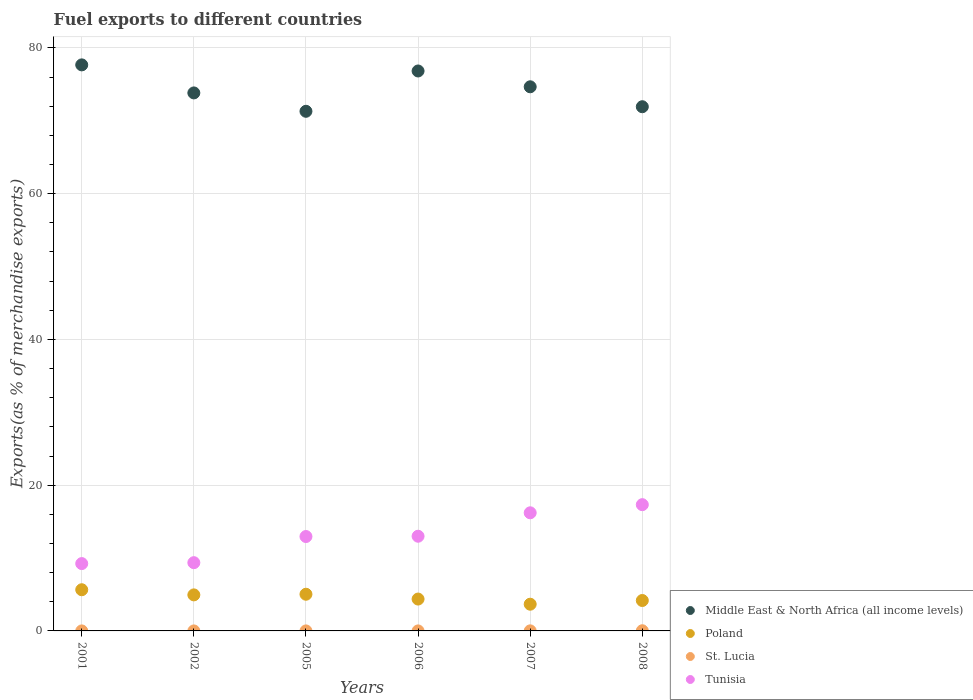What is the percentage of exports to different countries in Tunisia in 2005?
Provide a short and direct response. 12.95. Across all years, what is the maximum percentage of exports to different countries in Middle East & North Africa (all income levels)?
Offer a very short reply. 77.67. Across all years, what is the minimum percentage of exports to different countries in Middle East & North Africa (all income levels)?
Your response must be concise. 71.3. In which year was the percentage of exports to different countries in Poland minimum?
Provide a succinct answer. 2007. What is the total percentage of exports to different countries in St. Lucia in the graph?
Your answer should be compact. 0.04. What is the difference between the percentage of exports to different countries in Middle East & North Africa (all income levels) in 2007 and that in 2008?
Give a very brief answer. 2.74. What is the difference between the percentage of exports to different countries in St. Lucia in 2006 and the percentage of exports to different countries in Middle East & North Africa (all income levels) in 2001?
Make the answer very short. -77.67. What is the average percentage of exports to different countries in Poland per year?
Provide a succinct answer. 4.64. In the year 2007, what is the difference between the percentage of exports to different countries in Tunisia and percentage of exports to different countries in St. Lucia?
Your answer should be very brief. 16.2. What is the ratio of the percentage of exports to different countries in Middle East & North Africa (all income levels) in 2001 to that in 2005?
Ensure brevity in your answer.  1.09. Is the percentage of exports to different countries in Middle East & North Africa (all income levels) in 2002 less than that in 2006?
Your response must be concise. Yes. What is the difference between the highest and the second highest percentage of exports to different countries in Middle East & North Africa (all income levels)?
Provide a succinct answer. 0.84. What is the difference between the highest and the lowest percentage of exports to different countries in Middle East & North Africa (all income levels)?
Give a very brief answer. 6.37. In how many years, is the percentage of exports to different countries in St. Lucia greater than the average percentage of exports to different countries in St. Lucia taken over all years?
Offer a terse response. 2. Is it the case that in every year, the sum of the percentage of exports to different countries in Tunisia and percentage of exports to different countries in St. Lucia  is greater than the sum of percentage of exports to different countries in Middle East & North Africa (all income levels) and percentage of exports to different countries in Poland?
Provide a short and direct response. Yes. Is it the case that in every year, the sum of the percentage of exports to different countries in Tunisia and percentage of exports to different countries in St. Lucia  is greater than the percentage of exports to different countries in Poland?
Your answer should be compact. Yes. Does the percentage of exports to different countries in St. Lucia monotonically increase over the years?
Provide a succinct answer. No. Is the percentage of exports to different countries in Tunisia strictly greater than the percentage of exports to different countries in St. Lucia over the years?
Your response must be concise. Yes. Is the percentage of exports to different countries in Middle East & North Africa (all income levels) strictly less than the percentage of exports to different countries in Tunisia over the years?
Provide a succinct answer. No. How many dotlines are there?
Offer a terse response. 4. How many years are there in the graph?
Offer a very short reply. 6. Does the graph contain any zero values?
Offer a terse response. No. Does the graph contain grids?
Offer a very short reply. Yes. How are the legend labels stacked?
Give a very brief answer. Vertical. What is the title of the graph?
Make the answer very short. Fuel exports to different countries. Does "Bulgaria" appear as one of the legend labels in the graph?
Offer a very short reply. No. What is the label or title of the Y-axis?
Your answer should be compact. Exports(as % of merchandise exports). What is the Exports(as % of merchandise exports) in Middle East & North Africa (all income levels) in 2001?
Provide a succinct answer. 77.67. What is the Exports(as % of merchandise exports) of Poland in 2001?
Your answer should be compact. 5.65. What is the Exports(as % of merchandise exports) of St. Lucia in 2001?
Your answer should be compact. 0. What is the Exports(as % of merchandise exports) in Tunisia in 2001?
Make the answer very short. 9.24. What is the Exports(as % of merchandise exports) of Middle East & North Africa (all income levels) in 2002?
Offer a terse response. 73.82. What is the Exports(as % of merchandise exports) in Poland in 2002?
Give a very brief answer. 4.94. What is the Exports(as % of merchandise exports) in St. Lucia in 2002?
Offer a very short reply. 4.657797227082891e-6. What is the Exports(as % of merchandise exports) in Tunisia in 2002?
Your answer should be compact. 9.36. What is the Exports(as % of merchandise exports) of Middle East & North Africa (all income levels) in 2005?
Your response must be concise. 71.3. What is the Exports(as % of merchandise exports) in Poland in 2005?
Your answer should be compact. 5.03. What is the Exports(as % of merchandise exports) in St. Lucia in 2005?
Provide a short and direct response. 0. What is the Exports(as % of merchandise exports) in Tunisia in 2005?
Keep it short and to the point. 12.95. What is the Exports(as % of merchandise exports) of Middle East & North Africa (all income levels) in 2006?
Provide a short and direct response. 76.83. What is the Exports(as % of merchandise exports) of Poland in 2006?
Provide a succinct answer. 4.37. What is the Exports(as % of merchandise exports) of St. Lucia in 2006?
Your answer should be very brief. 0. What is the Exports(as % of merchandise exports) of Tunisia in 2006?
Provide a short and direct response. 12.99. What is the Exports(as % of merchandise exports) of Middle East & North Africa (all income levels) in 2007?
Keep it short and to the point. 74.66. What is the Exports(as % of merchandise exports) in Poland in 2007?
Offer a terse response. 3.67. What is the Exports(as % of merchandise exports) in St. Lucia in 2007?
Keep it short and to the point. 0.01. What is the Exports(as % of merchandise exports) of Tunisia in 2007?
Make the answer very short. 16.21. What is the Exports(as % of merchandise exports) in Middle East & North Africa (all income levels) in 2008?
Keep it short and to the point. 71.93. What is the Exports(as % of merchandise exports) in Poland in 2008?
Give a very brief answer. 4.17. What is the Exports(as % of merchandise exports) in St. Lucia in 2008?
Your response must be concise. 0.02. What is the Exports(as % of merchandise exports) of Tunisia in 2008?
Give a very brief answer. 17.32. Across all years, what is the maximum Exports(as % of merchandise exports) of Middle East & North Africa (all income levels)?
Ensure brevity in your answer.  77.67. Across all years, what is the maximum Exports(as % of merchandise exports) of Poland?
Make the answer very short. 5.65. Across all years, what is the maximum Exports(as % of merchandise exports) of St. Lucia?
Provide a short and direct response. 0.02. Across all years, what is the maximum Exports(as % of merchandise exports) in Tunisia?
Your answer should be compact. 17.32. Across all years, what is the minimum Exports(as % of merchandise exports) of Middle East & North Africa (all income levels)?
Give a very brief answer. 71.3. Across all years, what is the minimum Exports(as % of merchandise exports) in Poland?
Give a very brief answer. 3.67. Across all years, what is the minimum Exports(as % of merchandise exports) of St. Lucia?
Offer a very short reply. 4.657797227082891e-6. Across all years, what is the minimum Exports(as % of merchandise exports) of Tunisia?
Give a very brief answer. 9.24. What is the total Exports(as % of merchandise exports) of Middle East & North Africa (all income levels) in the graph?
Make the answer very short. 446.21. What is the total Exports(as % of merchandise exports) of Poland in the graph?
Your response must be concise. 27.84. What is the total Exports(as % of merchandise exports) of St. Lucia in the graph?
Offer a very short reply. 0.04. What is the total Exports(as % of merchandise exports) of Tunisia in the graph?
Offer a very short reply. 78.08. What is the difference between the Exports(as % of merchandise exports) in Middle East & North Africa (all income levels) in 2001 and that in 2002?
Offer a very short reply. 3.85. What is the difference between the Exports(as % of merchandise exports) in Poland in 2001 and that in 2002?
Your answer should be very brief. 0.71. What is the difference between the Exports(as % of merchandise exports) in St. Lucia in 2001 and that in 2002?
Provide a short and direct response. 0. What is the difference between the Exports(as % of merchandise exports) of Tunisia in 2001 and that in 2002?
Give a very brief answer. -0.13. What is the difference between the Exports(as % of merchandise exports) of Middle East & North Africa (all income levels) in 2001 and that in 2005?
Your answer should be compact. 6.37. What is the difference between the Exports(as % of merchandise exports) in Poland in 2001 and that in 2005?
Your answer should be very brief. 0.62. What is the difference between the Exports(as % of merchandise exports) in St. Lucia in 2001 and that in 2005?
Keep it short and to the point. -0. What is the difference between the Exports(as % of merchandise exports) in Tunisia in 2001 and that in 2005?
Offer a very short reply. -3.71. What is the difference between the Exports(as % of merchandise exports) in Middle East & North Africa (all income levels) in 2001 and that in 2006?
Offer a terse response. 0.84. What is the difference between the Exports(as % of merchandise exports) of Poland in 2001 and that in 2006?
Offer a very short reply. 1.28. What is the difference between the Exports(as % of merchandise exports) in St. Lucia in 2001 and that in 2006?
Your answer should be compact. -0. What is the difference between the Exports(as % of merchandise exports) in Tunisia in 2001 and that in 2006?
Your answer should be compact. -3.75. What is the difference between the Exports(as % of merchandise exports) in Middle East & North Africa (all income levels) in 2001 and that in 2007?
Your answer should be compact. 3.01. What is the difference between the Exports(as % of merchandise exports) in Poland in 2001 and that in 2007?
Make the answer very short. 1.99. What is the difference between the Exports(as % of merchandise exports) of St. Lucia in 2001 and that in 2007?
Your answer should be very brief. -0.01. What is the difference between the Exports(as % of merchandise exports) of Tunisia in 2001 and that in 2007?
Ensure brevity in your answer.  -6.97. What is the difference between the Exports(as % of merchandise exports) in Middle East & North Africa (all income levels) in 2001 and that in 2008?
Your answer should be very brief. 5.74. What is the difference between the Exports(as % of merchandise exports) in Poland in 2001 and that in 2008?
Your response must be concise. 1.48. What is the difference between the Exports(as % of merchandise exports) in St. Lucia in 2001 and that in 2008?
Provide a succinct answer. -0.02. What is the difference between the Exports(as % of merchandise exports) of Tunisia in 2001 and that in 2008?
Provide a succinct answer. -8.09. What is the difference between the Exports(as % of merchandise exports) in Middle East & North Africa (all income levels) in 2002 and that in 2005?
Offer a very short reply. 2.52. What is the difference between the Exports(as % of merchandise exports) in Poland in 2002 and that in 2005?
Offer a terse response. -0.09. What is the difference between the Exports(as % of merchandise exports) of St. Lucia in 2002 and that in 2005?
Provide a short and direct response. -0. What is the difference between the Exports(as % of merchandise exports) of Tunisia in 2002 and that in 2005?
Make the answer very short. -3.59. What is the difference between the Exports(as % of merchandise exports) of Middle East & North Africa (all income levels) in 2002 and that in 2006?
Make the answer very short. -3.01. What is the difference between the Exports(as % of merchandise exports) in Poland in 2002 and that in 2006?
Your answer should be very brief. 0.57. What is the difference between the Exports(as % of merchandise exports) of St. Lucia in 2002 and that in 2006?
Ensure brevity in your answer.  -0. What is the difference between the Exports(as % of merchandise exports) in Tunisia in 2002 and that in 2006?
Make the answer very short. -3.63. What is the difference between the Exports(as % of merchandise exports) in Middle East & North Africa (all income levels) in 2002 and that in 2007?
Keep it short and to the point. -0.84. What is the difference between the Exports(as % of merchandise exports) in Poland in 2002 and that in 2007?
Your response must be concise. 1.28. What is the difference between the Exports(as % of merchandise exports) in St. Lucia in 2002 and that in 2007?
Your answer should be compact. -0.01. What is the difference between the Exports(as % of merchandise exports) of Tunisia in 2002 and that in 2007?
Make the answer very short. -6.84. What is the difference between the Exports(as % of merchandise exports) of Middle East & North Africa (all income levels) in 2002 and that in 2008?
Provide a succinct answer. 1.89. What is the difference between the Exports(as % of merchandise exports) in Poland in 2002 and that in 2008?
Offer a very short reply. 0.77. What is the difference between the Exports(as % of merchandise exports) in St. Lucia in 2002 and that in 2008?
Provide a succinct answer. -0.02. What is the difference between the Exports(as % of merchandise exports) in Tunisia in 2002 and that in 2008?
Offer a very short reply. -7.96. What is the difference between the Exports(as % of merchandise exports) of Middle East & North Africa (all income levels) in 2005 and that in 2006?
Give a very brief answer. -5.53. What is the difference between the Exports(as % of merchandise exports) in Poland in 2005 and that in 2006?
Your answer should be compact. 0.66. What is the difference between the Exports(as % of merchandise exports) in St. Lucia in 2005 and that in 2006?
Make the answer very short. -0. What is the difference between the Exports(as % of merchandise exports) of Tunisia in 2005 and that in 2006?
Your response must be concise. -0.04. What is the difference between the Exports(as % of merchandise exports) in Middle East & North Africa (all income levels) in 2005 and that in 2007?
Make the answer very short. -3.36. What is the difference between the Exports(as % of merchandise exports) of Poland in 2005 and that in 2007?
Keep it short and to the point. 1.37. What is the difference between the Exports(as % of merchandise exports) of St. Lucia in 2005 and that in 2007?
Ensure brevity in your answer.  -0.01. What is the difference between the Exports(as % of merchandise exports) of Tunisia in 2005 and that in 2007?
Keep it short and to the point. -3.26. What is the difference between the Exports(as % of merchandise exports) in Middle East & North Africa (all income levels) in 2005 and that in 2008?
Your response must be concise. -0.63. What is the difference between the Exports(as % of merchandise exports) of Poland in 2005 and that in 2008?
Give a very brief answer. 0.86. What is the difference between the Exports(as % of merchandise exports) of St. Lucia in 2005 and that in 2008?
Make the answer very short. -0.02. What is the difference between the Exports(as % of merchandise exports) in Tunisia in 2005 and that in 2008?
Provide a succinct answer. -4.37. What is the difference between the Exports(as % of merchandise exports) of Middle East & North Africa (all income levels) in 2006 and that in 2007?
Your answer should be very brief. 2.17. What is the difference between the Exports(as % of merchandise exports) of Poland in 2006 and that in 2007?
Provide a short and direct response. 0.71. What is the difference between the Exports(as % of merchandise exports) in St. Lucia in 2006 and that in 2007?
Offer a terse response. -0.01. What is the difference between the Exports(as % of merchandise exports) in Tunisia in 2006 and that in 2007?
Ensure brevity in your answer.  -3.21. What is the difference between the Exports(as % of merchandise exports) in Middle East & North Africa (all income levels) in 2006 and that in 2008?
Your response must be concise. 4.91. What is the difference between the Exports(as % of merchandise exports) of Poland in 2006 and that in 2008?
Provide a short and direct response. 0.2. What is the difference between the Exports(as % of merchandise exports) in St. Lucia in 2006 and that in 2008?
Give a very brief answer. -0.02. What is the difference between the Exports(as % of merchandise exports) in Tunisia in 2006 and that in 2008?
Offer a very short reply. -4.33. What is the difference between the Exports(as % of merchandise exports) in Middle East & North Africa (all income levels) in 2007 and that in 2008?
Your answer should be very brief. 2.74. What is the difference between the Exports(as % of merchandise exports) of Poland in 2007 and that in 2008?
Offer a very short reply. -0.51. What is the difference between the Exports(as % of merchandise exports) of St. Lucia in 2007 and that in 2008?
Offer a very short reply. -0.01. What is the difference between the Exports(as % of merchandise exports) in Tunisia in 2007 and that in 2008?
Provide a short and direct response. -1.12. What is the difference between the Exports(as % of merchandise exports) of Middle East & North Africa (all income levels) in 2001 and the Exports(as % of merchandise exports) of Poland in 2002?
Your answer should be compact. 72.72. What is the difference between the Exports(as % of merchandise exports) of Middle East & North Africa (all income levels) in 2001 and the Exports(as % of merchandise exports) of St. Lucia in 2002?
Your response must be concise. 77.67. What is the difference between the Exports(as % of merchandise exports) in Middle East & North Africa (all income levels) in 2001 and the Exports(as % of merchandise exports) in Tunisia in 2002?
Offer a terse response. 68.3. What is the difference between the Exports(as % of merchandise exports) in Poland in 2001 and the Exports(as % of merchandise exports) in St. Lucia in 2002?
Provide a succinct answer. 5.65. What is the difference between the Exports(as % of merchandise exports) of Poland in 2001 and the Exports(as % of merchandise exports) of Tunisia in 2002?
Provide a short and direct response. -3.71. What is the difference between the Exports(as % of merchandise exports) of St. Lucia in 2001 and the Exports(as % of merchandise exports) of Tunisia in 2002?
Give a very brief answer. -9.36. What is the difference between the Exports(as % of merchandise exports) of Middle East & North Africa (all income levels) in 2001 and the Exports(as % of merchandise exports) of Poland in 2005?
Your response must be concise. 72.64. What is the difference between the Exports(as % of merchandise exports) of Middle East & North Africa (all income levels) in 2001 and the Exports(as % of merchandise exports) of St. Lucia in 2005?
Keep it short and to the point. 77.67. What is the difference between the Exports(as % of merchandise exports) in Middle East & North Africa (all income levels) in 2001 and the Exports(as % of merchandise exports) in Tunisia in 2005?
Your answer should be compact. 64.72. What is the difference between the Exports(as % of merchandise exports) in Poland in 2001 and the Exports(as % of merchandise exports) in St. Lucia in 2005?
Your response must be concise. 5.65. What is the difference between the Exports(as % of merchandise exports) in Poland in 2001 and the Exports(as % of merchandise exports) in Tunisia in 2005?
Ensure brevity in your answer.  -7.3. What is the difference between the Exports(as % of merchandise exports) of St. Lucia in 2001 and the Exports(as % of merchandise exports) of Tunisia in 2005?
Ensure brevity in your answer.  -12.95. What is the difference between the Exports(as % of merchandise exports) in Middle East & North Africa (all income levels) in 2001 and the Exports(as % of merchandise exports) in Poland in 2006?
Provide a succinct answer. 73.3. What is the difference between the Exports(as % of merchandise exports) of Middle East & North Africa (all income levels) in 2001 and the Exports(as % of merchandise exports) of St. Lucia in 2006?
Your answer should be compact. 77.67. What is the difference between the Exports(as % of merchandise exports) of Middle East & North Africa (all income levels) in 2001 and the Exports(as % of merchandise exports) of Tunisia in 2006?
Ensure brevity in your answer.  64.68. What is the difference between the Exports(as % of merchandise exports) of Poland in 2001 and the Exports(as % of merchandise exports) of St. Lucia in 2006?
Provide a short and direct response. 5.65. What is the difference between the Exports(as % of merchandise exports) in Poland in 2001 and the Exports(as % of merchandise exports) in Tunisia in 2006?
Ensure brevity in your answer.  -7.34. What is the difference between the Exports(as % of merchandise exports) of St. Lucia in 2001 and the Exports(as % of merchandise exports) of Tunisia in 2006?
Offer a very short reply. -12.99. What is the difference between the Exports(as % of merchandise exports) in Middle East & North Africa (all income levels) in 2001 and the Exports(as % of merchandise exports) in Poland in 2007?
Your answer should be very brief. 74. What is the difference between the Exports(as % of merchandise exports) of Middle East & North Africa (all income levels) in 2001 and the Exports(as % of merchandise exports) of St. Lucia in 2007?
Provide a succinct answer. 77.66. What is the difference between the Exports(as % of merchandise exports) in Middle East & North Africa (all income levels) in 2001 and the Exports(as % of merchandise exports) in Tunisia in 2007?
Offer a very short reply. 61.46. What is the difference between the Exports(as % of merchandise exports) of Poland in 2001 and the Exports(as % of merchandise exports) of St. Lucia in 2007?
Give a very brief answer. 5.64. What is the difference between the Exports(as % of merchandise exports) in Poland in 2001 and the Exports(as % of merchandise exports) in Tunisia in 2007?
Make the answer very short. -10.56. What is the difference between the Exports(as % of merchandise exports) in St. Lucia in 2001 and the Exports(as % of merchandise exports) in Tunisia in 2007?
Provide a succinct answer. -16.21. What is the difference between the Exports(as % of merchandise exports) of Middle East & North Africa (all income levels) in 2001 and the Exports(as % of merchandise exports) of Poland in 2008?
Your response must be concise. 73.5. What is the difference between the Exports(as % of merchandise exports) in Middle East & North Africa (all income levels) in 2001 and the Exports(as % of merchandise exports) in St. Lucia in 2008?
Your answer should be very brief. 77.64. What is the difference between the Exports(as % of merchandise exports) in Middle East & North Africa (all income levels) in 2001 and the Exports(as % of merchandise exports) in Tunisia in 2008?
Make the answer very short. 60.34. What is the difference between the Exports(as % of merchandise exports) of Poland in 2001 and the Exports(as % of merchandise exports) of St. Lucia in 2008?
Your answer should be very brief. 5.63. What is the difference between the Exports(as % of merchandise exports) in Poland in 2001 and the Exports(as % of merchandise exports) in Tunisia in 2008?
Your answer should be compact. -11.67. What is the difference between the Exports(as % of merchandise exports) in St. Lucia in 2001 and the Exports(as % of merchandise exports) in Tunisia in 2008?
Your response must be concise. -17.32. What is the difference between the Exports(as % of merchandise exports) of Middle East & North Africa (all income levels) in 2002 and the Exports(as % of merchandise exports) of Poland in 2005?
Offer a terse response. 68.79. What is the difference between the Exports(as % of merchandise exports) of Middle East & North Africa (all income levels) in 2002 and the Exports(as % of merchandise exports) of St. Lucia in 2005?
Make the answer very short. 73.82. What is the difference between the Exports(as % of merchandise exports) of Middle East & North Africa (all income levels) in 2002 and the Exports(as % of merchandise exports) of Tunisia in 2005?
Offer a very short reply. 60.87. What is the difference between the Exports(as % of merchandise exports) of Poland in 2002 and the Exports(as % of merchandise exports) of St. Lucia in 2005?
Keep it short and to the point. 4.94. What is the difference between the Exports(as % of merchandise exports) of Poland in 2002 and the Exports(as % of merchandise exports) of Tunisia in 2005?
Ensure brevity in your answer.  -8.01. What is the difference between the Exports(as % of merchandise exports) in St. Lucia in 2002 and the Exports(as % of merchandise exports) in Tunisia in 2005?
Make the answer very short. -12.95. What is the difference between the Exports(as % of merchandise exports) in Middle East & North Africa (all income levels) in 2002 and the Exports(as % of merchandise exports) in Poland in 2006?
Provide a short and direct response. 69.45. What is the difference between the Exports(as % of merchandise exports) in Middle East & North Africa (all income levels) in 2002 and the Exports(as % of merchandise exports) in St. Lucia in 2006?
Your answer should be compact. 73.82. What is the difference between the Exports(as % of merchandise exports) of Middle East & North Africa (all income levels) in 2002 and the Exports(as % of merchandise exports) of Tunisia in 2006?
Your answer should be very brief. 60.83. What is the difference between the Exports(as % of merchandise exports) in Poland in 2002 and the Exports(as % of merchandise exports) in St. Lucia in 2006?
Ensure brevity in your answer.  4.94. What is the difference between the Exports(as % of merchandise exports) in Poland in 2002 and the Exports(as % of merchandise exports) in Tunisia in 2006?
Ensure brevity in your answer.  -8.05. What is the difference between the Exports(as % of merchandise exports) of St. Lucia in 2002 and the Exports(as % of merchandise exports) of Tunisia in 2006?
Provide a short and direct response. -12.99. What is the difference between the Exports(as % of merchandise exports) in Middle East & North Africa (all income levels) in 2002 and the Exports(as % of merchandise exports) in Poland in 2007?
Give a very brief answer. 70.16. What is the difference between the Exports(as % of merchandise exports) of Middle East & North Africa (all income levels) in 2002 and the Exports(as % of merchandise exports) of St. Lucia in 2007?
Keep it short and to the point. 73.81. What is the difference between the Exports(as % of merchandise exports) of Middle East & North Africa (all income levels) in 2002 and the Exports(as % of merchandise exports) of Tunisia in 2007?
Give a very brief answer. 57.61. What is the difference between the Exports(as % of merchandise exports) in Poland in 2002 and the Exports(as % of merchandise exports) in St. Lucia in 2007?
Provide a succinct answer. 4.93. What is the difference between the Exports(as % of merchandise exports) in Poland in 2002 and the Exports(as % of merchandise exports) in Tunisia in 2007?
Provide a short and direct response. -11.26. What is the difference between the Exports(as % of merchandise exports) in St. Lucia in 2002 and the Exports(as % of merchandise exports) in Tunisia in 2007?
Your response must be concise. -16.21. What is the difference between the Exports(as % of merchandise exports) in Middle East & North Africa (all income levels) in 2002 and the Exports(as % of merchandise exports) in Poland in 2008?
Offer a very short reply. 69.65. What is the difference between the Exports(as % of merchandise exports) of Middle East & North Africa (all income levels) in 2002 and the Exports(as % of merchandise exports) of St. Lucia in 2008?
Provide a succinct answer. 73.8. What is the difference between the Exports(as % of merchandise exports) of Middle East & North Africa (all income levels) in 2002 and the Exports(as % of merchandise exports) of Tunisia in 2008?
Your response must be concise. 56.5. What is the difference between the Exports(as % of merchandise exports) in Poland in 2002 and the Exports(as % of merchandise exports) in St. Lucia in 2008?
Provide a short and direct response. 4.92. What is the difference between the Exports(as % of merchandise exports) in Poland in 2002 and the Exports(as % of merchandise exports) in Tunisia in 2008?
Keep it short and to the point. -12.38. What is the difference between the Exports(as % of merchandise exports) of St. Lucia in 2002 and the Exports(as % of merchandise exports) of Tunisia in 2008?
Provide a short and direct response. -17.32. What is the difference between the Exports(as % of merchandise exports) of Middle East & North Africa (all income levels) in 2005 and the Exports(as % of merchandise exports) of Poland in 2006?
Your response must be concise. 66.93. What is the difference between the Exports(as % of merchandise exports) in Middle East & North Africa (all income levels) in 2005 and the Exports(as % of merchandise exports) in St. Lucia in 2006?
Your response must be concise. 71.3. What is the difference between the Exports(as % of merchandise exports) in Middle East & North Africa (all income levels) in 2005 and the Exports(as % of merchandise exports) in Tunisia in 2006?
Your response must be concise. 58.31. What is the difference between the Exports(as % of merchandise exports) in Poland in 2005 and the Exports(as % of merchandise exports) in St. Lucia in 2006?
Your answer should be very brief. 5.03. What is the difference between the Exports(as % of merchandise exports) of Poland in 2005 and the Exports(as % of merchandise exports) of Tunisia in 2006?
Provide a short and direct response. -7.96. What is the difference between the Exports(as % of merchandise exports) of St. Lucia in 2005 and the Exports(as % of merchandise exports) of Tunisia in 2006?
Your answer should be very brief. -12.99. What is the difference between the Exports(as % of merchandise exports) in Middle East & North Africa (all income levels) in 2005 and the Exports(as % of merchandise exports) in Poland in 2007?
Keep it short and to the point. 67.63. What is the difference between the Exports(as % of merchandise exports) of Middle East & North Africa (all income levels) in 2005 and the Exports(as % of merchandise exports) of St. Lucia in 2007?
Your answer should be very brief. 71.29. What is the difference between the Exports(as % of merchandise exports) of Middle East & North Africa (all income levels) in 2005 and the Exports(as % of merchandise exports) of Tunisia in 2007?
Offer a very short reply. 55.09. What is the difference between the Exports(as % of merchandise exports) in Poland in 2005 and the Exports(as % of merchandise exports) in St. Lucia in 2007?
Offer a terse response. 5.02. What is the difference between the Exports(as % of merchandise exports) of Poland in 2005 and the Exports(as % of merchandise exports) of Tunisia in 2007?
Your answer should be compact. -11.17. What is the difference between the Exports(as % of merchandise exports) in St. Lucia in 2005 and the Exports(as % of merchandise exports) in Tunisia in 2007?
Keep it short and to the point. -16.21. What is the difference between the Exports(as % of merchandise exports) of Middle East & North Africa (all income levels) in 2005 and the Exports(as % of merchandise exports) of Poland in 2008?
Make the answer very short. 67.13. What is the difference between the Exports(as % of merchandise exports) in Middle East & North Africa (all income levels) in 2005 and the Exports(as % of merchandise exports) in St. Lucia in 2008?
Your answer should be compact. 71.28. What is the difference between the Exports(as % of merchandise exports) in Middle East & North Africa (all income levels) in 2005 and the Exports(as % of merchandise exports) in Tunisia in 2008?
Your answer should be very brief. 53.98. What is the difference between the Exports(as % of merchandise exports) of Poland in 2005 and the Exports(as % of merchandise exports) of St. Lucia in 2008?
Provide a succinct answer. 5.01. What is the difference between the Exports(as % of merchandise exports) in Poland in 2005 and the Exports(as % of merchandise exports) in Tunisia in 2008?
Your answer should be very brief. -12.29. What is the difference between the Exports(as % of merchandise exports) in St. Lucia in 2005 and the Exports(as % of merchandise exports) in Tunisia in 2008?
Your answer should be compact. -17.32. What is the difference between the Exports(as % of merchandise exports) of Middle East & North Africa (all income levels) in 2006 and the Exports(as % of merchandise exports) of Poland in 2007?
Your answer should be compact. 73.17. What is the difference between the Exports(as % of merchandise exports) of Middle East & North Africa (all income levels) in 2006 and the Exports(as % of merchandise exports) of St. Lucia in 2007?
Keep it short and to the point. 76.82. What is the difference between the Exports(as % of merchandise exports) in Middle East & North Africa (all income levels) in 2006 and the Exports(as % of merchandise exports) in Tunisia in 2007?
Make the answer very short. 60.62. What is the difference between the Exports(as % of merchandise exports) in Poland in 2006 and the Exports(as % of merchandise exports) in St. Lucia in 2007?
Your answer should be compact. 4.36. What is the difference between the Exports(as % of merchandise exports) of Poland in 2006 and the Exports(as % of merchandise exports) of Tunisia in 2007?
Give a very brief answer. -11.84. What is the difference between the Exports(as % of merchandise exports) of St. Lucia in 2006 and the Exports(as % of merchandise exports) of Tunisia in 2007?
Your answer should be compact. -16.21. What is the difference between the Exports(as % of merchandise exports) of Middle East & North Africa (all income levels) in 2006 and the Exports(as % of merchandise exports) of Poland in 2008?
Offer a terse response. 72.66. What is the difference between the Exports(as % of merchandise exports) in Middle East & North Africa (all income levels) in 2006 and the Exports(as % of merchandise exports) in St. Lucia in 2008?
Make the answer very short. 76.81. What is the difference between the Exports(as % of merchandise exports) of Middle East & North Africa (all income levels) in 2006 and the Exports(as % of merchandise exports) of Tunisia in 2008?
Keep it short and to the point. 59.51. What is the difference between the Exports(as % of merchandise exports) of Poland in 2006 and the Exports(as % of merchandise exports) of St. Lucia in 2008?
Offer a terse response. 4.35. What is the difference between the Exports(as % of merchandise exports) of Poland in 2006 and the Exports(as % of merchandise exports) of Tunisia in 2008?
Make the answer very short. -12.95. What is the difference between the Exports(as % of merchandise exports) in St. Lucia in 2006 and the Exports(as % of merchandise exports) in Tunisia in 2008?
Your answer should be very brief. -17.32. What is the difference between the Exports(as % of merchandise exports) of Middle East & North Africa (all income levels) in 2007 and the Exports(as % of merchandise exports) of Poland in 2008?
Keep it short and to the point. 70.49. What is the difference between the Exports(as % of merchandise exports) of Middle East & North Africa (all income levels) in 2007 and the Exports(as % of merchandise exports) of St. Lucia in 2008?
Your answer should be very brief. 74.64. What is the difference between the Exports(as % of merchandise exports) of Middle East & North Africa (all income levels) in 2007 and the Exports(as % of merchandise exports) of Tunisia in 2008?
Offer a terse response. 57.34. What is the difference between the Exports(as % of merchandise exports) of Poland in 2007 and the Exports(as % of merchandise exports) of St. Lucia in 2008?
Provide a succinct answer. 3.64. What is the difference between the Exports(as % of merchandise exports) in Poland in 2007 and the Exports(as % of merchandise exports) in Tunisia in 2008?
Make the answer very short. -13.66. What is the difference between the Exports(as % of merchandise exports) in St. Lucia in 2007 and the Exports(as % of merchandise exports) in Tunisia in 2008?
Ensure brevity in your answer.  -17.31. What is the average Exports(as % of merchandise exports) in Middle East & North Africa (all income levels) per year?
Provide a succinct answer. 74.37. What is the average Exports(as % of merchandise exports) of Poland per year?
Ensure brevity in your answer.  4.64. What is the average Exports(as % of merchandise exports) of St. Lucia per year?
Ensure brevity in your answer.  0.01. What is the average Exports(as % of merchandise exports) in Tunisia per year?
Provide a short and direct response. 13.01. In the year 2001, what is the difference between the Exports(as % of merchandise exports) of Middle East & North Africa (all income levels) and Exports(as % of merchandise exports) of Poland?
Your response must be concise. 72.02. In the year 2001, what is the difference between the Exports(as % of merchandise exports) of Middle East & North Africa (all income levels) and Exports(as % of merchandise exports) of St. Lucia?
Your answer should be very brief. 77.67. In the year 2001, what is the difference between the Exports(as % of merchandise exports) of Middle East & North Africa (all income levels) and Exports(as % of merchandise exports) of Tunisia?
Provide a succinct answer. 68.43. In the year 2001, what is the difference between the Exports(as % of merchandise exports) of Poland and Exports(as % of merchandise exports) of St. Lucia?
Your answer should be compact. 5.65. In the year 2001, what is the difference between the Exports(as % of merchandise exports) of Poland and Exports(as % of merchandise exports) of Tunisia?
Offer a very short reply. -3.59. In the year 2001, what is the difference between the Exports(as % of merchandise exports) in St. Lucia and Exports(as % of merchandise exports) in Tunisia?
Your response must be concise. -9.24. In the year 2002, what is the difference between the Exports(as % of merchandise exports) in Middle East & North Africa (all income levels) and Exports(as % of merchandise exports) in Poland?
Provide a succinct answer. 68.88. In the year 2002, what is the difference between the Exports(as % of merchandise exports) in Middle East & North Africa (all income levels) and Exports(as % of merchandise exports) in St. Lucia?
Give a very brief answer. 73.82. In the year 2002, what is the difference between the Exports(as % of merchandise exports) of Middle East & North Africa (all income levels) and Exports(as % of merchandise exports) of Tunisia?
Offer a very short reply. 64.46. In the year 2002, what is the difference between the Exports(as % of merchandise exports) of Poland and Exports(as % of merchandise exports) of St. Lucia?
Provide a succinct answer. 4.94. In the year 2002, what is the difference between the Exports(as % of merchandise exports) in Poland and Exports(as % of merchandise exports) in Tunisia?
Give a very brief answer. -4.42. In the year 2002, what is the difference between the Exports(as % of merchandise exports) of St. Lucia and Exports(as % of merchandise exports) of Tunisia?
Offer a very short reply. -9.36. In the year 2005, what is the difference between the Exports(as % of merchandise exports) of Middle East & North Africa (all income levels) and Exports(as % of merchandise exports) of Poland?
Give a very brief answer. 66.27. In the year 2005, what is the difference between the Exports(as % of merchandise exports) of Middle East & North Africa (all income levels) and Exports(as % of merchandise exports) of St. Lucia?
Provide a short and direct response. 71.3. In the year 2005, what is the difference between the Exports(as % of merchandise exports) in Middle East & North Africa (all income levels) and Exports(as % of merchandise exports) in Tunisia?
Provide a short and direct response. 58.35. In the year 2005, what is the difference between the Exports(as % of merchandise exports) in Poland and Exports(as % of merchandise exports) in St. Lucia?
Your answer should be very brief. 5.03. In the year 2005, what is the difference between the Exports(as % of merchandise exports) of Poland and Exports(as % of merchandise exports) of Tunisia?
Provide a short and direct response. -7.92. In the year 2005, what is the difference between the Exports(as % of merchandise exports) in St. Lucia and Exports(as % of merchandise exports) in Tunisia?
Give a very brief answer. -12.95. In the year 2006, what is the difference between the Exports(as % of merchandise exports) in Middle East & North Africa (all income levels) and Exports(as % of merchandise exports) in Poland?
Offer a very short reply. 72.46. In the year 2006, what is the difference between the Exports(as % of merchandise exports) in Middle East & North Africa (all income levels) and Exports(as % of merchandise exports) in St. Lucia?
Offer a very short reply. 76.83. In the year 2006, what is the difference between the Exports(as % of merchandise exports) in Middle East & North Africa (all income levels) and Exports(as % of merchandise exports) in Tunisia?
Provide a short and direct response. 63.84. In the year 2006, what is the difference between the Exports(as % of merchandise exports) in Poland and Exports(as % of merchandise exports) in St. Lucia?
Your response must be concise. 4.37. In the year 2006, what is the difference between the Exports(as % of merchandise exports) of Poland and Exports(as % of merchandise exports) of Tunisia?
Give a very brief answer. -8.62. In the year 2006, what is the difference between the Exports(as % of merchandise exports) of St. Lucia and Exports(as % of merchandise exports) of Tunisia?
Your response must be concise. -12.99. In the year 2007, what is the difference between the Exports(as % of merchandise exports) of Middle East & North Africa (all income levels) and Exports(as % of merchandise exports) of Poland?
Give a very brief answer. 71. In the year 2007, what is the difference between the Exports(as % of merchandise exports) in Middle East & North Africa (all income levels) and Exports(as % of merchandise exports) in St. Lucia?
Make the answer very short. 74.65. In the year 2007, what is the difference between the Exports(as % of merchandise exports) of Middle East & North Africa (all income levels) and Exports(as % of merchandise exports) of Tunisia?
Provide a short and direct response. 58.45. In the year 2007, what is the difference between the Exports(as % of merchandise exports) in Poland and Exports(as % of merchandise exports) in St. Lucia?
Provide a short and direct response. 3.66. In the year 2007, what is the difference between the Exports(as % of merchandise exports) of Poland and Exports(as % of merchandise exports) of Tunisia?
Your answer should be compact. -12.54. In the year 2007, what is the difference between the Exports(as % of merchandise exports) in St. Lucia and Exports(as % of merchandise exports) in Tunisia?
Your response must be concise. -16.2. In the year 2008, what is the difference between the Exports(as % of merchandise exports) in Middle East & North Africa (all income levels) and Exports(as % of merchandise exports) in Poland?
Keep it short and to the point. 67.75. In the year 2008, what is the difference between the Exports(as % of merchandise exports) in Middle East & North Africa (all income levels) and Exports(as % of merchandise exports) in St. Lucia?
Provide a short and direct response. 71.9. In the year 2008, what is the difference between the Exports(as % of merchandise exports) in Middle East & North Africa (all income levels) and Exports(as % of merchandise exports) in Tunisia?
Offer a very short reply. 54.6. In the year 2008, what is the difference between the Exports(as % of merchandise exports) of Poland and Exports(as % of merchandise exports) of St. Lucia?
Make the answer very short. 4.15. In the year 2008, what is the difference between the Exports(as % of merchandise exports) in Poland and Exports(as % of merchandise exports) in Tunisia?
Offer a very short reply. -13.15. In the year 2008, what is the difference between the Exports(as % of merchandise exports) of St. Lucia and Exports(as % of merchandise exports) of Tunisia?
Keep it short and to the point. -17.3. What is the ratio of the Exports(as % of merchandise exports) of Middle East & North Africa (all income levels) in 2001 to that in 2002?
Provide a short and direct response. 1.05. What is the ratio of the Exports(as % of merchandise exports) of St. Lucia in 2001 to that in 2002?
Ensure brevity in your answer.  123.86. What is the ratio of the Exports(as % of merchandise exports) of Tunisia in 2001 to that in 2002?
Provide a short and direct response. 0.99. What is the ratio of the Exports(as % of merchandise exports) in Middle East & North Africa (all income levels) in 2001 to that in 2005?
Make the answer very short. 1.09. What is the ratio of the Exports(as % of merchandise exports) of Poland in 2001 to that in 2005?
Provide a short and direct response. 1.12. What is the ratio of the Exports(as % of merchandise exports) in St. Lucia in 2001 to that in 2005?
Offer a terse response. 0.57. What is the ratio of the Exports(as % of merchandise exports) in Tunisia in 2001 to that in 2005?
Ensure brevity in your answer.  0.71. What is the ratio of the Exports(as % of merchandise exports) of Middle East & North Africa (all income levels) in 2001 to that in 2006?
Your response must be concise. 1.01. What is the ratio of the Exports(as % of merchandise exports) of Poland in 2001 to that in 2006?
Your answer should be compact. 1.29. What is the ratio of the Exports(as % of merchandise exports) of St. Lucia in 2001 to that in 2006?
Provide a short and direct response. 0.35. What is the ratio of the Exports(as % of merchandise exports) in Tunisia in 2001 to that in 2006?
Offer a terse response. 0.71. What is the ratio of the Exports(as % of merchandise exports) in Middle East & North Africa (all income levels) in 2001 to that in 2007?
Ensure brevity in your answer.  1.04. What is the ratio of the Exports(as % of merchandise exports) in Poland in 2001 to that in 2007?
Offer a terse response. 1.54. What is the ratio of the Exports(as % of merchandise exports) in St. Lucia in 2001 to that in 2007?
Provide a succinct answer. 0.06. What is the ratio of the Exports(as % of merchandise exports) of Tunisia in 2001 to that in 2007?
Your answer should be very brief. 0.57. What is the ratio of the Exports(as % of merchandise exports) of Middle East & North Africa (all income levels) in 2001 to that in 2008?
Give a very brief answer. 1.08. What is the ratio of the Exports(as % of merchandise exports) in Poland in 2001 to that in 2008?
Give a very brief answer. 1.35. What is the ratio of the Exports(as % of merchandise exports) of St. Lucia in 2001 to that in 2008?
Provide a succinct answer. 0.02. What is the ratio of the Exports(as % of merchandise exports) in Tunisia in 2001 to that in 2008?
Your answer should be very brief. 0.53. What is the ratio of the Exports(as % of merchandise exports) of Middle East & North Africa (all income levels) in 2002 to that in 2005?
Ensure brevity in your answer.  1.04. What is the ratio of the Exports(as % of merchandise exports) in Poland in 2002 to that in 2005?
Make the answer very short. 0.98. What is the ratio of the Exports(as % of merchandise exports) of St. Lucia in 2002 to that in 2005?
Your answer should be very brief. 0. What is the ratio of the Exports(as % of merchandise exports) in Tunisia in 2002 to that in 2005?
Provide a succinct answer. 0.72. What is the ratio of the Exports(as % of merchandise exports) in Middle East & North Africa (all income levels) in 2002 to that in 2006?
Your answer should be compact. 0.96. What is the ratio of the Exports(as % of merchandise exports) in Poland in 2002 to that in 2006?
Give a very brief answer. 1.13. What is the ratio of the Exports(as % of merchandise exports) of St. Lucia in 2002 to that in 2006?
Offer a terse response. 0. What is the ratio of the Exports(as % of merchandise exports) of Tunisia in 2002 to that in 2006?
Provide a succinct answer. 0.72. What is the ratio of the Exports(as % of merchandise exports) in Middle East & North Africa (all income levels) in 2002 to that in 2007?
Offer a very short reply. 0.99. What is the ratio of the Exports(as % of merchandise exports) of Poland in 2002 to that in 2007?
Offer a very short reply. 1.35. What is the ratio of the Exports(as % of merchandise exports) of St. Lucia in 2002 to that in 2007?
Your response must be concise. 0. What is the ratio of the Exports(as % of merchandise exports) of Tunisia in 2002 to that in 2007?
Offer a very short reply. 0.58. What is the ratio of the Exports(as % of merchandise exports) in Middle East & North Africa (all income levels) in 2002 to that in 2008?
Keep it short and to the point. 1.03. What is the ratio of the Exports(as % of merchandise exports) of Poland in 2002 to that in 2008?
Your answer should be very brief. 1.18. What is the ratio of the Exports(as % of merchandise exports) in St. Lucia in 2002 to that in 2008?
Offer a very short reply. 0. What is the ratio of the Exports(as % of merchandise exports) of Tunisia in 2002 to that in 2008?
Provide a short and direct response. 0.54. What is the ratio of the Exports(as % of merchandise exports) of Middle East & North Africa (all income levels) in 2005 to that in 2006?
Offer a very short reply. 0.93. What is the ratio of the Exports(as % of merchandise exports) of Poland in 2005 to that in 2006?
Your response must be concise. 1.15. What is the ratio of the Exports(as % of merchandise exports) in St. Lucia in 2005 to that in 2006?
Ensure brevity in your answer.  0.61. What is the ratio of the Exports(as % of merchandise exports) of Middle East & North Africa (all income levels) in 2005 to that in 2007?
Provide a succinct answer. 0.95. What is the ratio of the Exports(as % of merchandise exports) of Poland in 2005 to that in 2007?
Ensure brevity in your answer.  1.37. What is the ratio of the Exports(as % of merchandise exports) in St. Lucia in 2005 to that in 2007?
Your answer should be compact. 0.1. What is the ratio of the Exports(as % of merchandise exports) in Tunisia in 2005 to that in 2007?
Provide a succinct answer. 0.8. What is the ratio of the Exports(as % of merchandise exports) of Middle East & North Africa (all income levels) in 2005 to that in 2008?
Your answer should be very brief. 0.99. What is the ratio of the Exports(as % of merchandise exports) of Poland in 2005 to that in 2008?
Your response must be concise. 1.21. What is the ratio of the Exports(as % of merchandise exports) of St. Lucia in 2005 to that in 2008?
Your response must be concise. 0.04. What is the ratio of the Exports(as % of merchandise exports) in Tunisia in 2005 to that in 2008?
Your response must be concise. 0.75. What is the ratio of the Exports(as % of merchandise exports) of Middle East & North Africa (all income levels) in 2006 to that in 2007?
Make the answer very short. 1.03. What is the ratio of the Exports(as % of merchandise exports) of Poland in 2006 to that in 2007?
Your response must be concise. 1.19. What is the ratio of the Exports(as % of merchandise exports) in St. Lucia in 2006 to that in 2007?
Your answer should be compact. 0.17. What is the ratio of the Exports(as % of merchandise exports) of Tunisia in 2006 to that in 2007?
Make the answer very short. 0.8. What is the ratio of the Exports(as % of merchandise exports) in Middle East & North Africa (all income levels) in 2006 to that in 2008?
Provide a succinct answer. 1.07. What is the ratio of the Exports(as % of merchandise exports) of Poland in 2006 to that in 2008?
Ensure brevity in your answer.  1.05. What is the ratio of the Exports(as % of merchandise exports) in St. Lucia in 2006 to that in 2008?
Give a very brief answer. 0.07. What is the ratio of the Exports(as % of merchandise exports) of Middle East & North Africa (all income levels) in 2007 to that in 2008?
Keep it short and to the point. 1.04. What is the ratio of the Exports(as % of merchandise exports) in Poland in 2007 to that in 2008?
Make the answer very short. 0.88. What is the ratio of the Exports(as % of merchandise exports) in St. Lucia in 2007 to that in 2008?
Offer a terse response. 0.4. What is the ratio of the Exports(as % of merchandise exports) in Tunisia in 2007 to that in 2008?
Provide a short and direct response. 0.94. What is the difference between the highest and the second highest Exports(as % of merchandise exports) in Middle East & North Africa (all income levels)?
Provide a short and direct response. 0.84. What is the difference between the highest and the second highest Exports(as % of merchandise exports) in Poland?
Your answer should be compact. 0.62. What is the difference between the highest and the second highest Exports(as % of merchandise exports) of St. Lucia?
Provide a succinct answer. 0.01. What is the difference between the highest and the second highest Exports(as % of merchandise exports) in Tunisia?
Your answer should be very brief. 1.12. What is the difference between the highest and the lowest Exports(as % of merchandise exports) in Middle East & North Africa (all income levels)?
Offer a very short reply. 6.37. What is the difference between the highest and the lowest Exports(as % of merchandise exports) of Poland?
Your answer should be compact. 1.99. What is the difference between the highest and the lowest Exports(as % of merchandise exports) of St. Lucia?
Provide a short and direct response. 0.02. What is the difference between the highest and the lowest Exports(as % of merchandise exports) in Tunisia?
Keep it short and to the point. 8.09. 